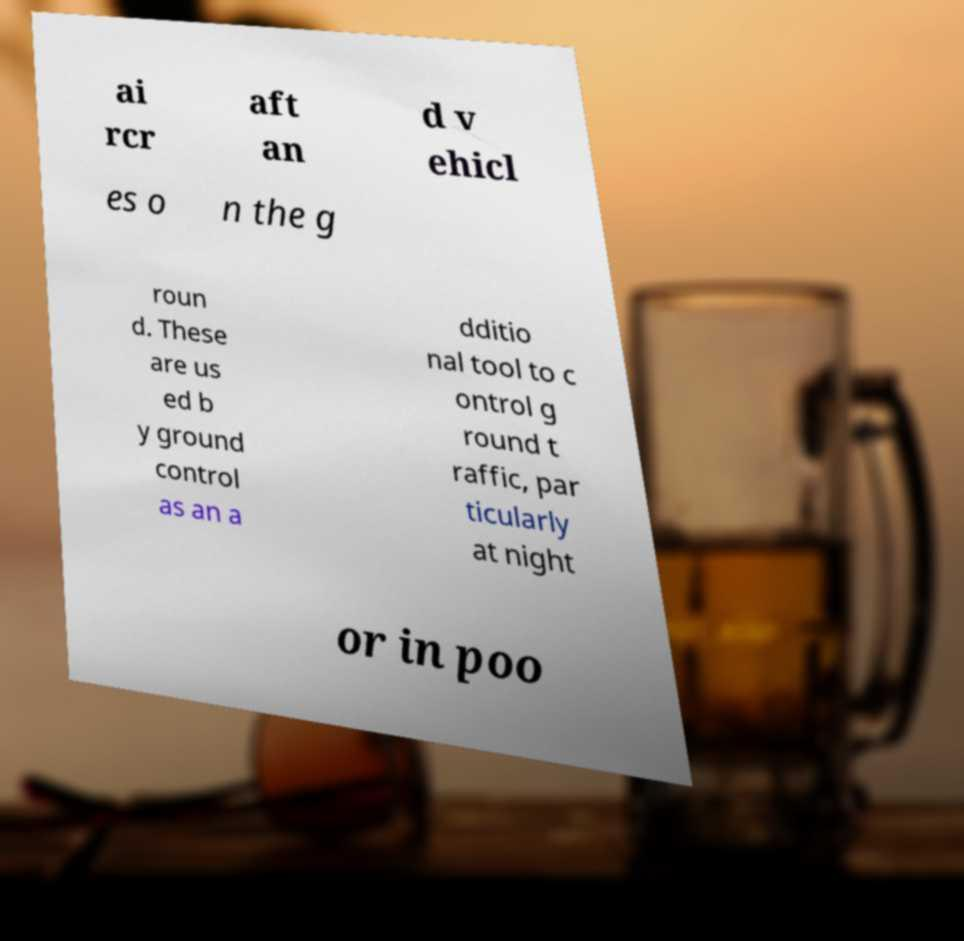What messages or text are displayed in this image? I need them in a readable, typed format. ai rcr aft an d v ehicl es o n the g roun d. These are us ed b y ground control as an a dditio nal tool to c ontrol g round t raffic, par ticularly at night or in poo 